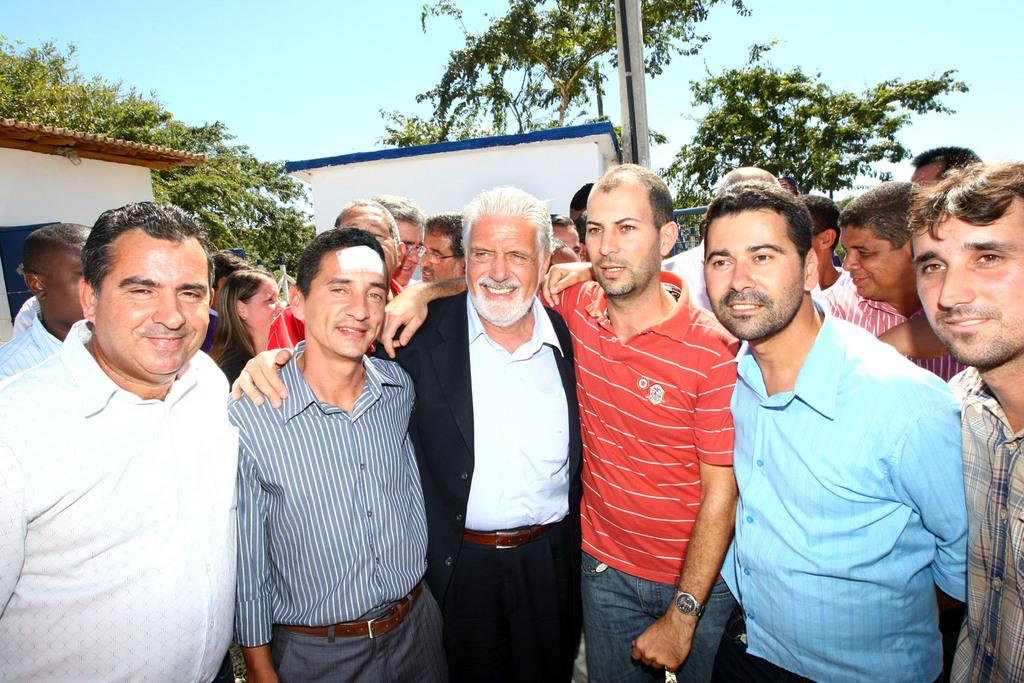What can be seen in the image? There are people standing in the image. What is visible in the background of the image? There are houses, trees, sky, and a pole in the background of the image. How many rings are being worn by the servant in the image? There is no servant or rings present in the image. What type of kite can be seen flying in the image? There is no kite present in the image. 